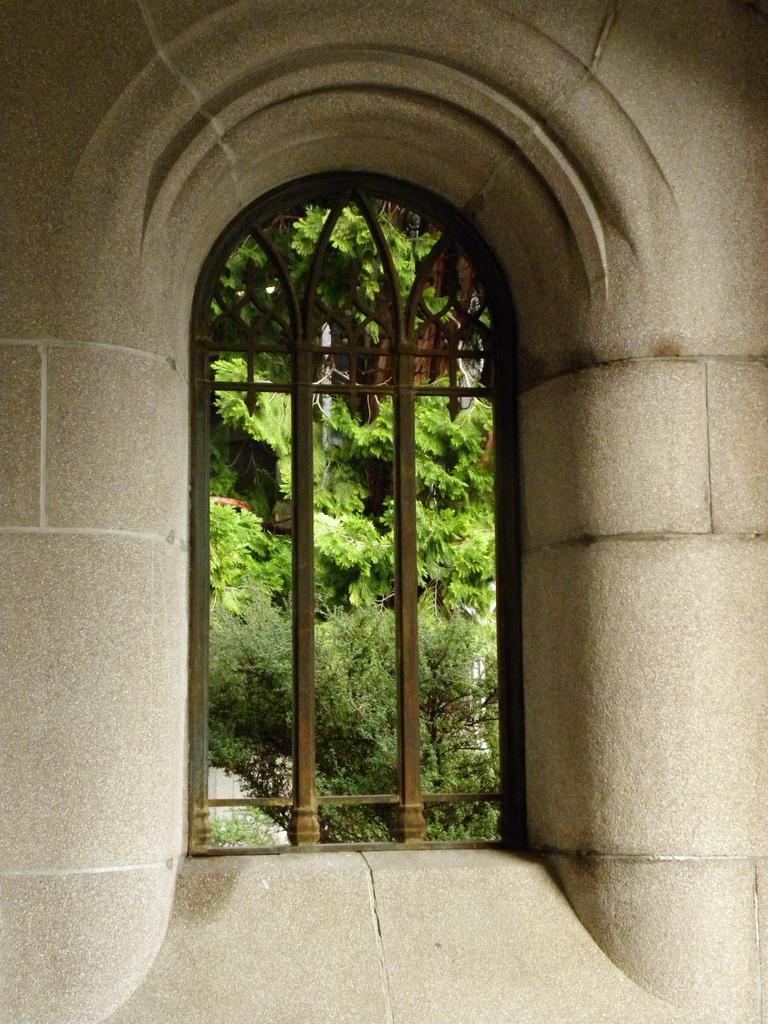How would you summarize this image in a sentence or two? In this picture we can see the wall, window and from window we can see trees. 